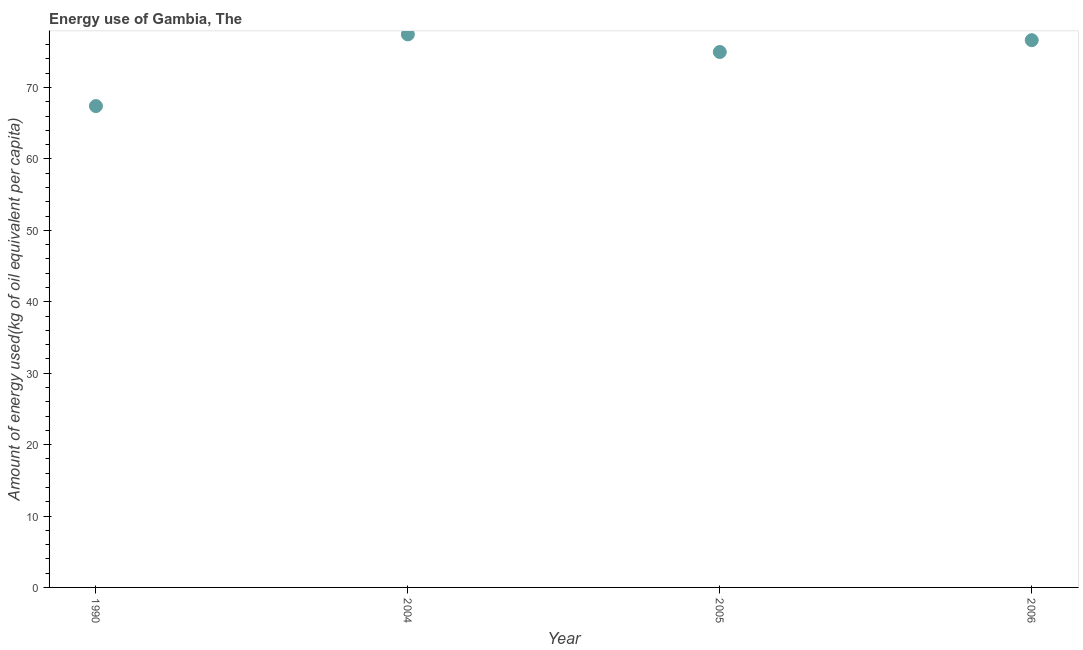What is the amount of energy used in 2004?
Offer a terse response. 77.43. Across all years, what is the maximum amount of energy used?
Provide a succinct answer. 77.43. Across all years, what is the minimum amount of energy used?
Your response must be concise. 67.4. What is the sum of the amount of energy used?
Keep it short and to the point. 296.43. What is the difference between the amount of energy used in 2004 and 2005?
Ensure brevity in your answer.  2.46. What is the average amount of energy used per year?
Your response must be concise. 74.11. What is the median amount of energy used?
Ensure brevity in your answer.  75.8. In how many years, is the amount of energy used greater than 26 kg?
Offer a terse response. 4. What is the ratio of the amount of energy used in 2004 to that in 2006?
Provide a short and direct response. 1.01. Is the difference between the amount of energy used in 1990 and 2005 greater than the difference between any two years?
Your response must be concise. No. What is the difference between the highest and the second highest amount of energy used?
Your answer should be very brief. 0.81. Is the sum of the amount of energy used in 1990 and 2005 greater than the maximum amount of energy used across all years?
Offer a terse response. Yes. What is the difference between the highest and the lowest amount of energy used?
Give a very brief answer. 10.04. Does the amount of energy used monotonically increase over the years?
Your answer should be compact. No. How many dotlines are there?
Give a very brief answer. 1. Are the values on the major ticks of Y-axis written in scientific E-notation?
Keep it short and to the point. No. Does the graph contain any zero values?
Make the answer very short. No. Does the graph contain grids?
Ensure brevity in your answer.  No. What is the title of the graph?
Ensure brevity in your answer.  Energy use of Gambia, The. What is the label or title of the X-axis?
Provide a short and direct response. Year. What is the label or title of the Y-axis?
Your answer should be compact. Amount of energy used(kg of oil equivalent per capita). What is the Amount of energy used(kg of oil equivalent per capita) in 1990?
Your response must be concise. 67.4. What is the Amount of energy used(kg of oil equivalent per capita) in 2004?
Make the answer very short. 77.43. What is the Amount of energy used(kg of oil equivalent per capita) in 2005?
Make the answer very short. 74.97. What is the Amount of energy used(kg of oil equivalent per capita) in 2006?
Your answer should be compact. 76.63. What is the difference between the Amount of energy used(kg of oil equivalent per capita) in 1990 and 2004?
Keep it short and to the point. -10.04. What is the difference between the Amount of energy used(kg of oil equivalent per capita) in 1990 and 2005?
Provide a succinct answer. -7.57. What is the difference between the Amount of energy used(kg of oil equivalent per capita) in 1990 and 2006?
Provide a short and direct response. -9.23. What is the difference between the Amount of energy used(kg of oil equivalent per capita) in 2004 and 2005?
Offer a very short reply. 2.46. What is the difference between the Amount of energy used(kg of oil equivalent per capita) in 2004 and 2006?
Your answer should be very brief. 0.81. What is the difference between the Amount of energy used(kg of oil equivalent per capita) in 2005 and 2006?
Provide a short and direct response. -1.65. What is the ratio of the Amount of energy used(kg of oil equivalent per capita) in 1990 to that in 2004?
Provide a succinct answer. 0.87. What is the ratio of the Amount of energy used(kg of oil equivalent per capita) in 1990 to that in 2005?
Keep it short and to the point. 0.9. What is the ratio of the Amount of energy used(kg of oil equivalent per capita) in 1990 to that in 2006?
Your answer should be compact. 0.88. What is the ratio of the Amount of energy used(kg of oil equivalent per capita) in 2004 to that in 2005?
Make the answer very short. 1.03. 